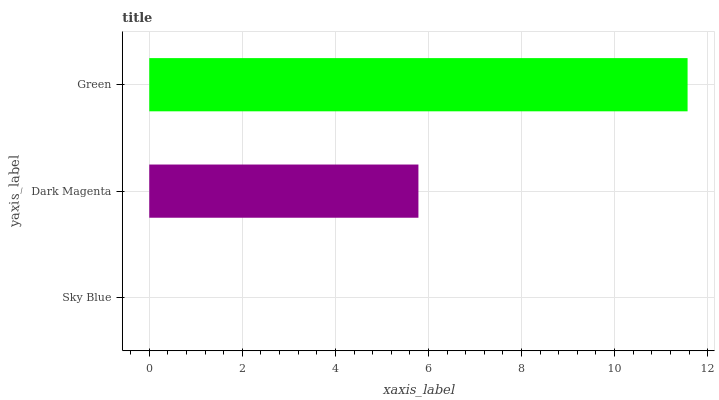Is Sky Blue the minimum?
Answer yes or no. Yes. Is Green the maximum?
Answer yes or no. Yes. Is Dark Magenta the minimum?
Answer yes or no. No. Is Dark Magenta the maximum?
Answer yes or no. No. Is Dark Magenta greater than Sky Blue?
Answer yes or no. Yes. Is Sky Blue less than Dark Magenta?
Answer yes or no. Yes. Is Sky Blue greater than Dark Magenta?
Answer yes or no. No. Is Dark Magenta less than Sky Blue?
Answer yes or no. No. Is Dark Magenta the high median?
Answer yes or no. Yes. Is Dark Magenta the low median?
Answer yes or no. Yes. Is Sky Blue the high median?
Answer yes or no. No. Is Green the low median?
Answer yes or no. No. 